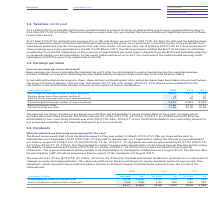According to Bt Group Plc's financial document, How is basic earnings per share calculated? calculated by dividing the profit after tax attributable to equity shareholders by the weighted average number of shares in issue after deducting the own shares held by employee share ownership trusts and treasury shares.. The document states: "per share calculated? Basic earnings per share is calculated by dividing the profit after tax attributable to equity shareholders by the weighted aver..." Also, What was the option amount which was excluded from the calculation of total diluted number of shares in 2019? According to the financial document, 36m shares. The relevant text states: "ere the impact of these is dilutive. Options over 36m shares (2017/18: 23m shares, 2016/17: 27m shares) were excluded from the calculation of the total diluted..." Also, What was the  Basic weighted average number of shares (millions)  in 2019? According to the financial document, 9,912 (in millions). The relevant text states: "asic weighted average number of shares (millions) 9,912 9,911 9,938 Dilutive shares from share options (millions) 6 2 27 Dilutive shares from executive sha..." Also, can you calculate: What was the change in the Basic weighted average number of shares (millions) from 2018 to 2019? Based on the calculation: 9,912 - 9,911, the result is 1 (in millions). This is based on the information: "eighted average number of shares (millions) 9,912 9,911 9,938 Dilutive shares from share options (millions) 6 2 27 Dilutive shares from executive share awa asic weighted average number of shares (mill..." The key data points involved are: 9,911, 9,912. Also, can you calculate: What is the average Dilutive shares from share options (millions) in 2017-2019? To answer this question, I need to perform calculations using the financial data. The calculation is: (6 + 2 + 27) / 3, which equals 11.67 (in millions). This is based on the information: "938 Dilutive shares from share options (millions) 6 2 27 Dilutive shares from executive share awards (millions) 57 48 29 8 Dilutive shares from share options (millions) 6 2 27 Dilutive shares from exe..." The key data points involved are: 2, 27. Also, can you calculate: What is the percentage change in the Dilutive shares from executive share awards (millions) from 2018 to 2019? To answer this question, I need to perform calculations using the financial data. The calculation is: 57 / 48 - 1, which equals 18.75 (percentage). This is based on the information: "ive shares from executive share awards (millions) 57 48 29 shares from executive share awards (millions) 57 48 29..." The key data points involved are: 48, 57. 